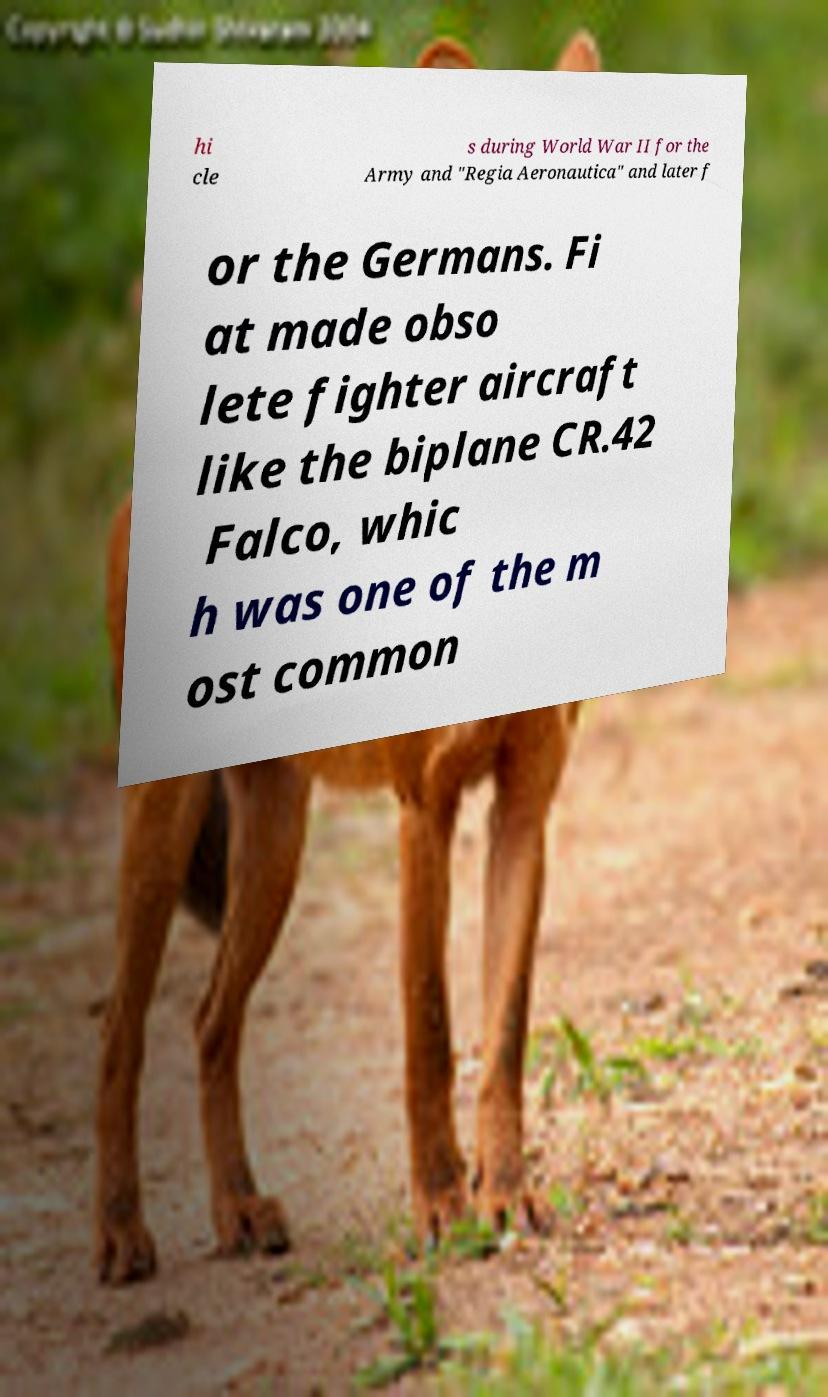Can you read and provide the text displayed in the image?This photo seems to have some interesting text. Can you extract and type it out for me? hi cle s during World War II for the Army and "Regia Aeronautica" and later f or the Germans. Fi at made obso lete fighter aircraft like the biplane CR.42 Falco, whic h was one of the m ost common 